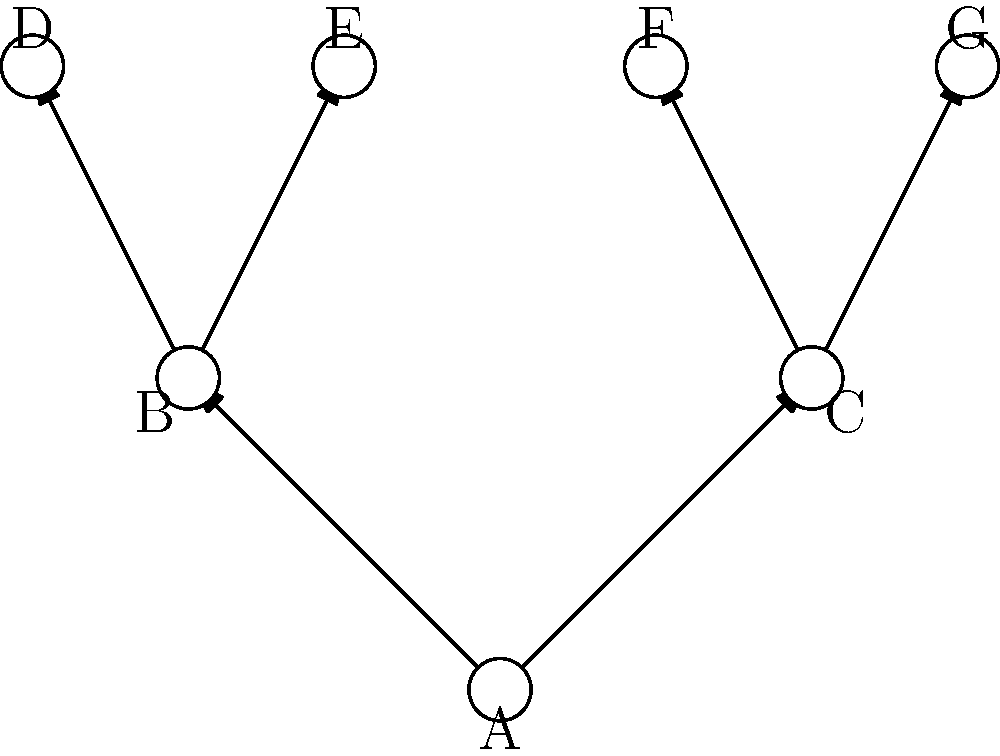Given the phylogenetic tree shown above, which represents evolutionary relationships among species A through G, consider the symmetry group of this tree. What is the order of this group? To determine the order of the symmetry group for this phylogenetic tree, we need to follow these steps:

1) First, identify the symmetries in the tree. In this case, we can see that the tree is asymmetric, with different branching patterns on the left and right sides.

2) The only symmetry operation that leaves this tree unchanged is the identity operation (doing nothing).

3) In group theory, the identity element alone forms a group called the trivial group.

4) The order of a group is defined as the number of elements in the group.

5) Since our symmetry group contains only the identity element, it has only one element.

Therefore, the order of the symmetry group for this phylogenetic tree is 1.

This result is significant in phylogenetic analysis because it indicates that the tree has a unique topology, which can provide strong evidence for specific evolutionary relationships among the species represented.
Answer: 1 